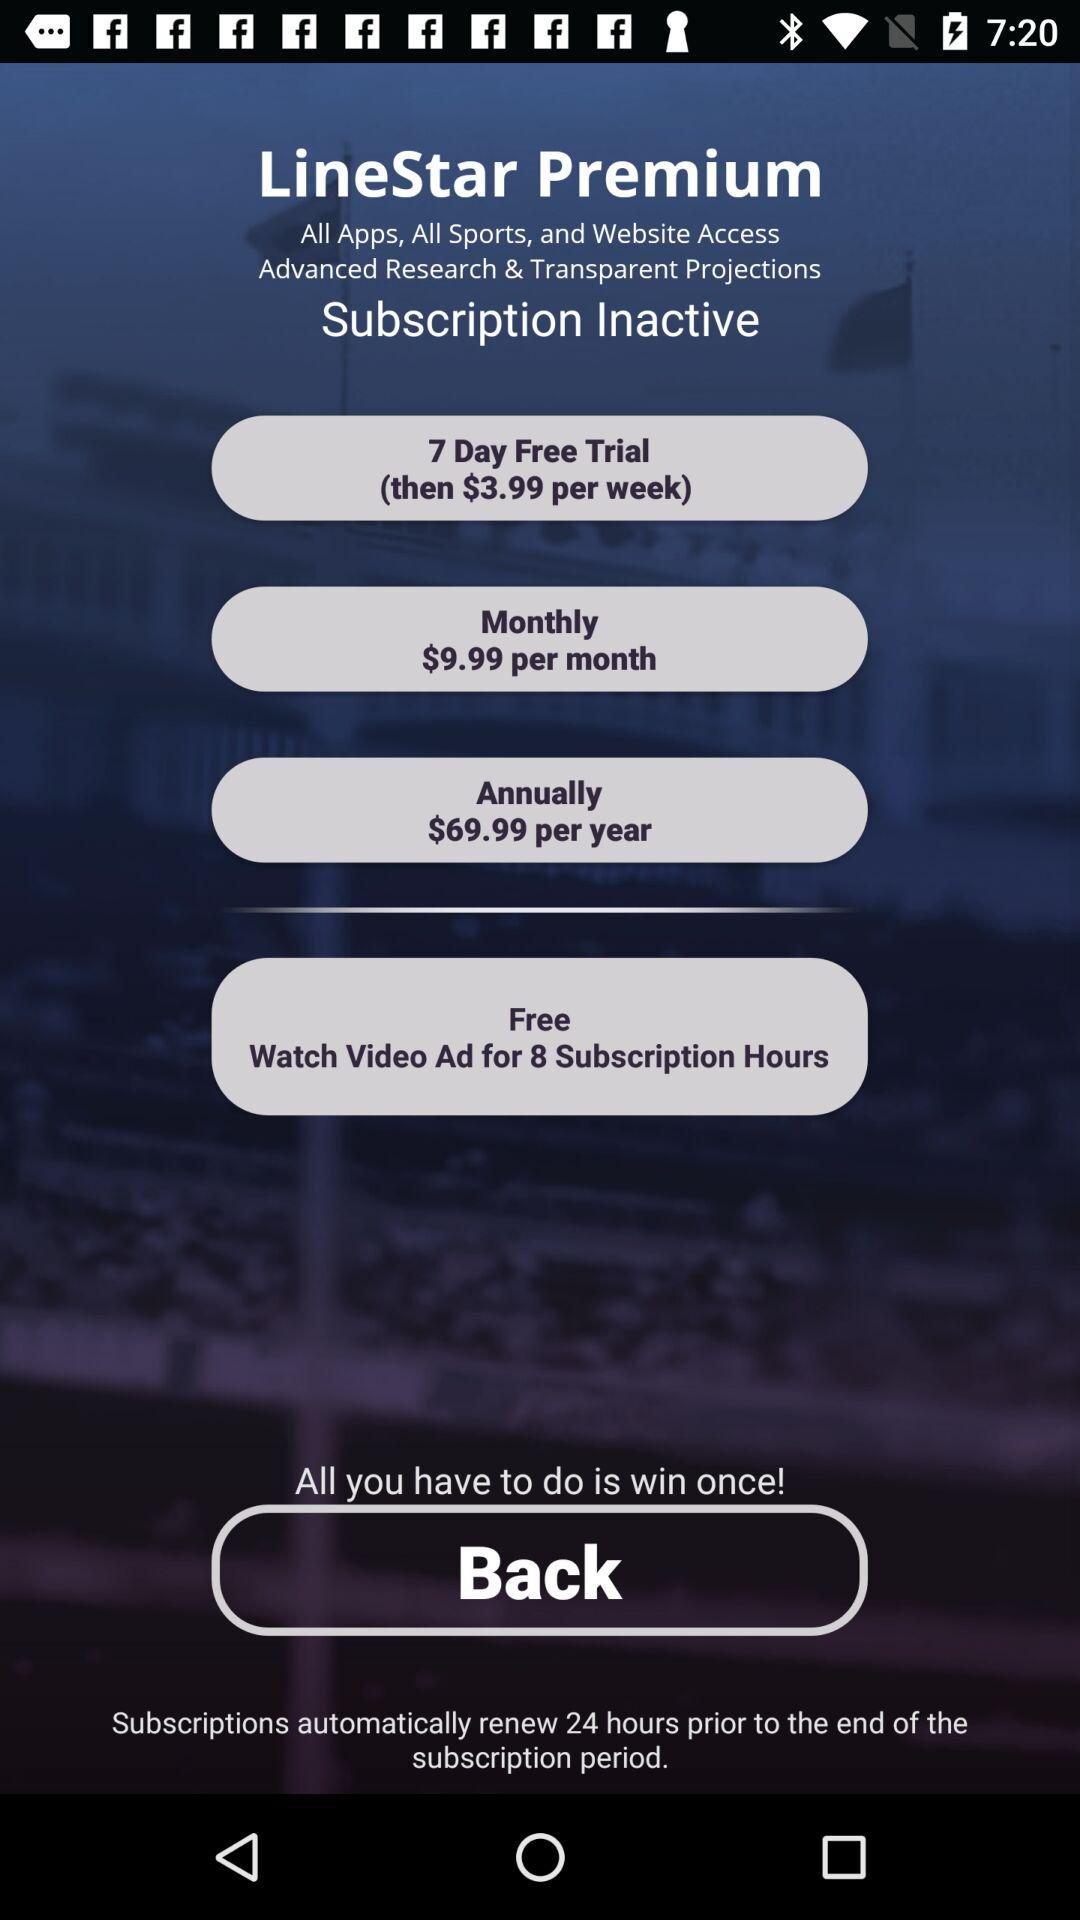What is the annual cost? The annual cost is $69.99. 